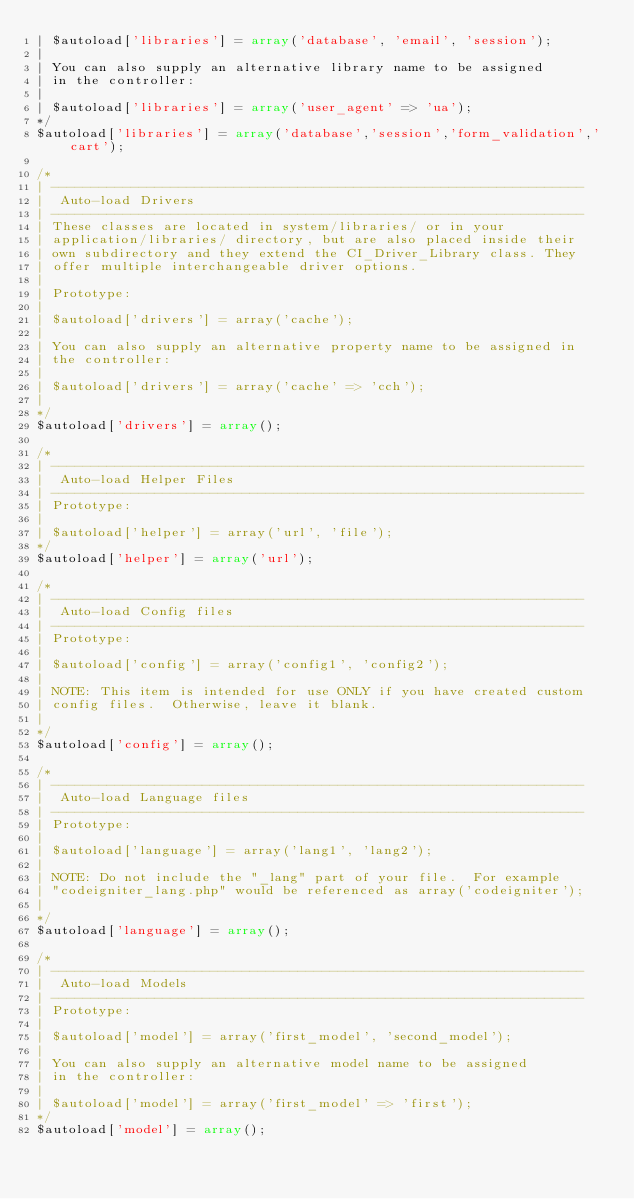<code> <loc_0><loc_0><loc_500><loc_500><_PHP_>|	$autoload['libraries'] = array('database', 'email', 'session');
|
| You can also supply an alternative library name to be assigned
| in the controller:
|
|	$autoload['libraries'] = array('user_agent' => 'ua');
*/
$autoload['libraries'] = array('database','session','form_validation','cart');

/*
| -------------------------------------------------------------------
|  Auto-load Drivers
| -------------------------------------------------------------------
| These classes are located in system/libraries/ or in your
| application/libraries/ directory, but are also placed inside their
| own subdirectory and they extend the CI_Driver_Library class. They
| offer multiple interchangeable driver options.
|
| Prototype:
|
|	$autoload['drivers'] = array('cache');
|
| You can also supply an alternative property name to be assigned in
| the controller:
|
|	$autoload['drivers'] = array('cache' => 'cch');
|
*/
$autoload['drivers'] = array();

/*
| -------------------------------------------------------------------
|  Auto-load Helper Files
| -------------------------------------------------------------------
| Prototype:
|
|	$autoload['helper'] = array('url', 'file');
*/
$autoload['helper'] = array('url');

/*
| -------------------------------------------------------------------
|  Auto-load Config files
| -------------------------------------------------------------------
| Prototype:
|
|	$autoload['config'] = array('config1', 'config2');
|
| NOTE: This item is intended for use ONLY if you have created custom
| config files.  Otherwise, leave it blank.
|
*/
$autoload['config'] = array();

/*
| -------------------------------------------------------------------
|  Auto-load Language files
| -------------------------------------------------------------------
| Prototype:
|
|	$autoload['language'] = array('lang1', 'lang2');
|
| NOTE: Do not include the "_lang" part of your file.  For example
| "codeigniter_lang.php" would be referenced as array('codeigniter');
|
*/
$autoload['language'] = array();

/*
| -------------------------------------------------------------------
|  Auto-load Models
| -------------------------------------------------------------------
| Prototype:
|
|	$autoload['model'] = array('first_model', 'second_model');
|
| You can also supply an alternative model name to be assigned
| in the controller:
|
|	$autoload['model'] = array('first_model' => 'first');
*/
$autoload['model'] = array();
</code> 